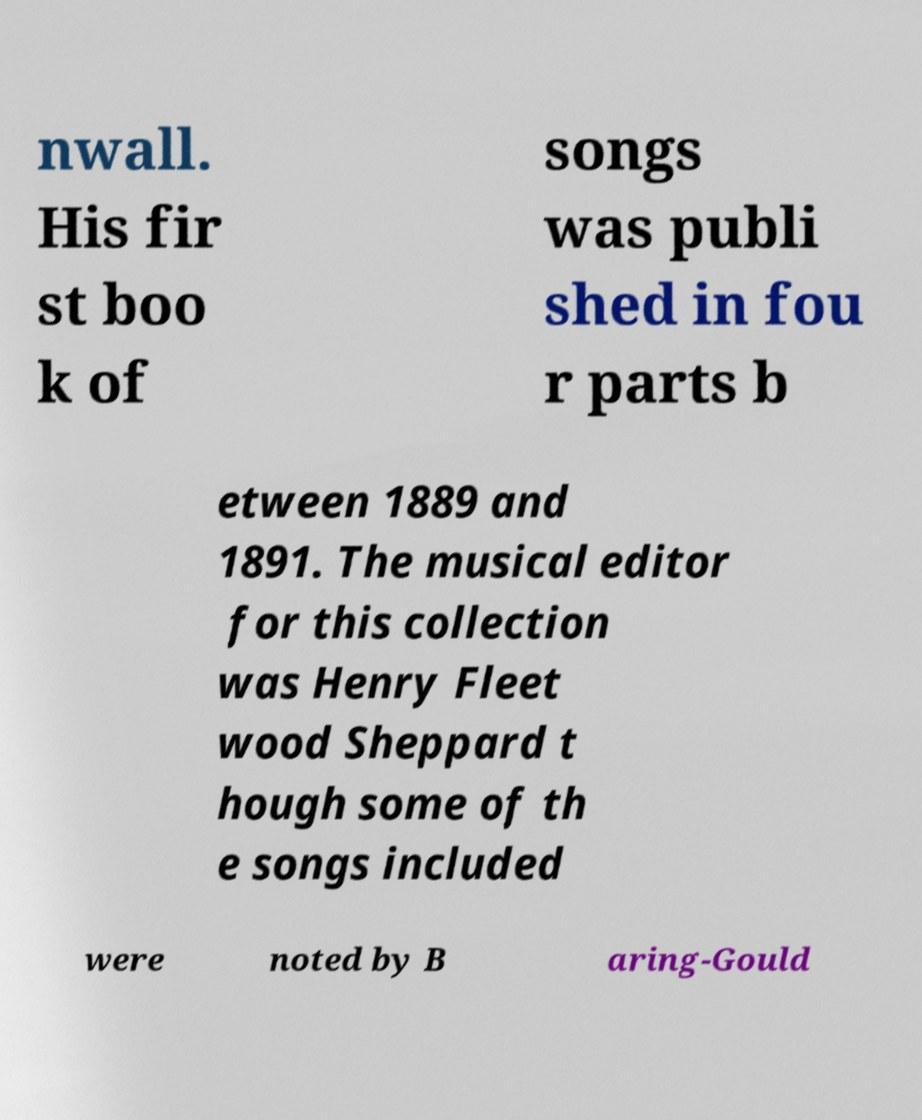Could you extract and type out the text from this image? nwall. His fir st boo k of songs was publi shed in fou r parts b etween 1889 and 1891. The musical editor for this collection was Henry Fleet wood Sheppard t hough some of th e songs included were noted by B aring-Gould 